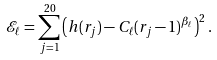Convert formula to latex. <formula><loc_0><loc_0><loc_500><loc_500>\mathcal { E } _ { \ell } = \sum _ { j = 1 } ^ { 2 0 } \left ( h ( r _ { j } ) - C _ { \ell } ( r _ { j } - 1 ) ^ { \beta _ { \ell } } \right ) ^ { 2 } .</formula> 